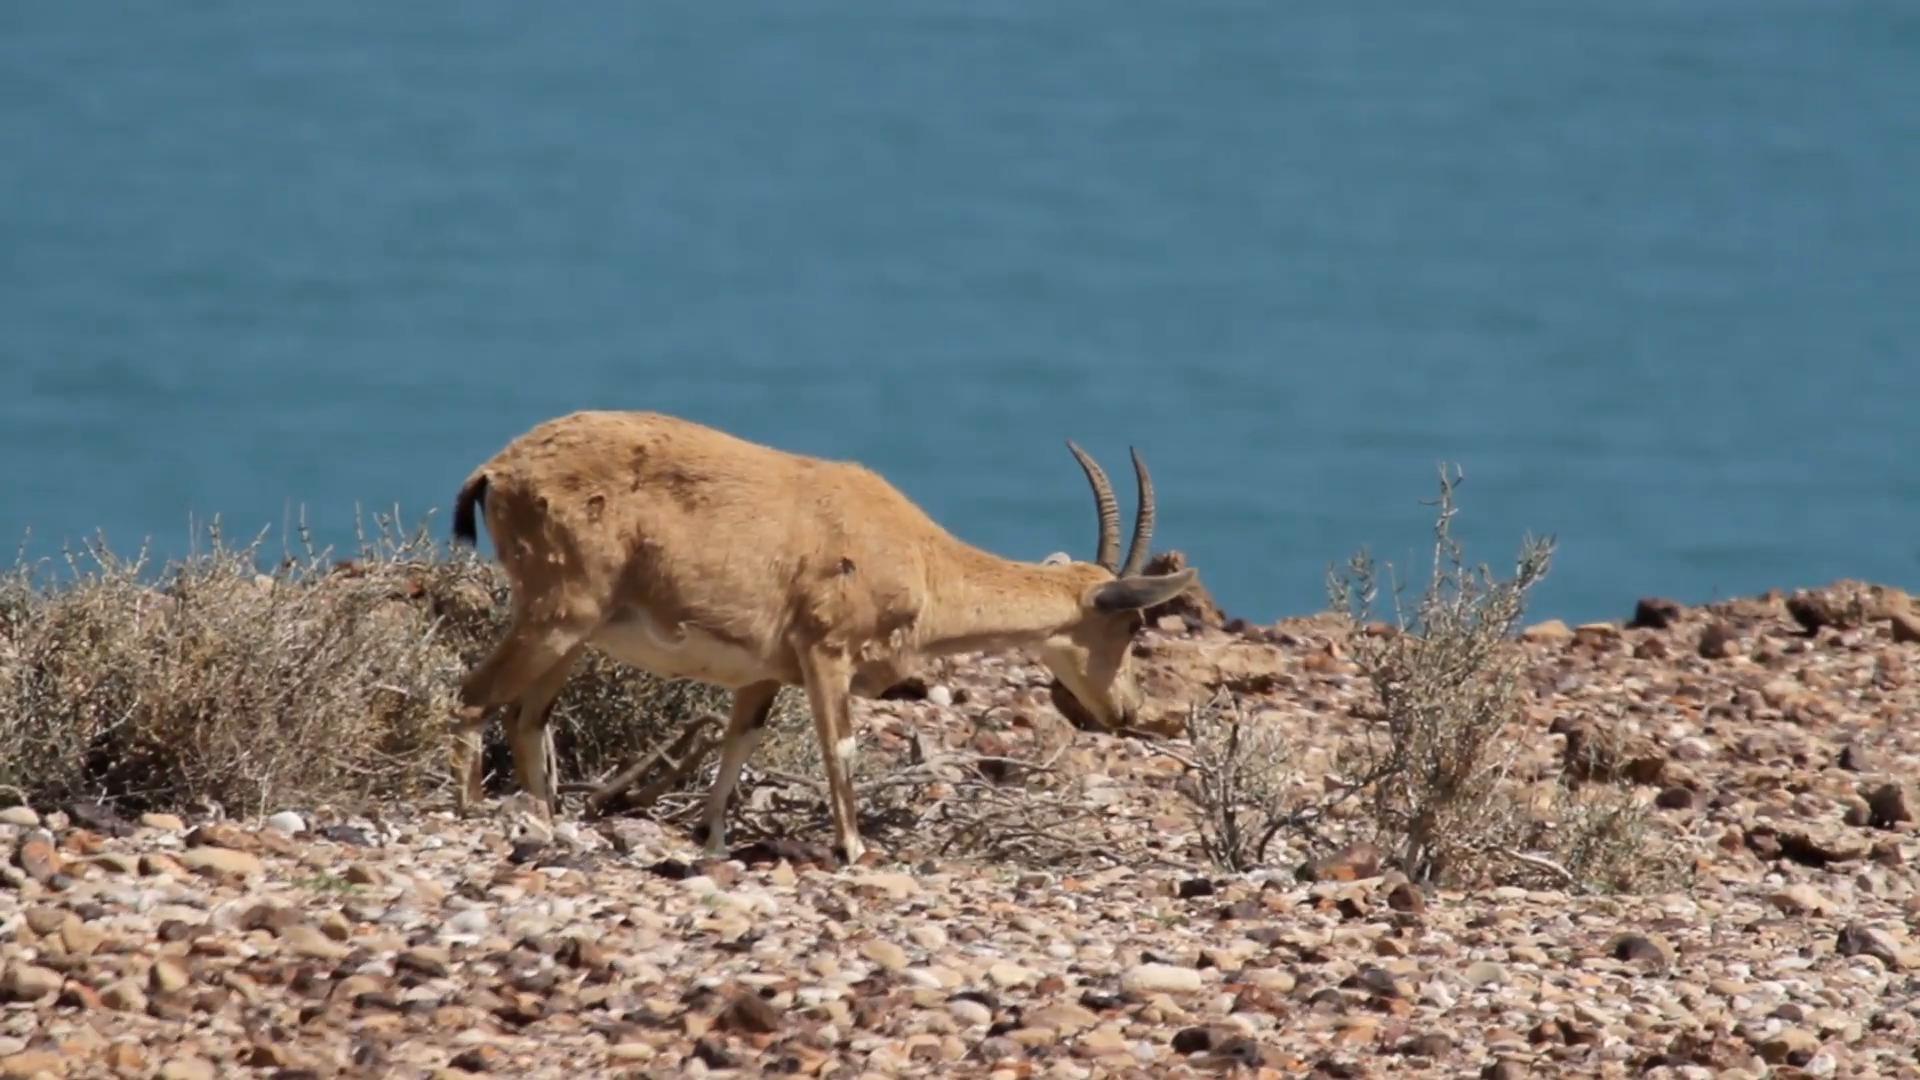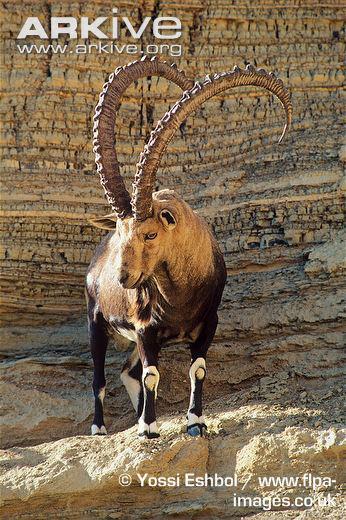The first image is the image on the left, the second image is the image on the right. Evaluate the accuracy of this statement regarding the images: "The left image contains a bigger horned animal and at least one smaller animal without a set of prominent horns.". Is it true? Answer yes or no. No. 